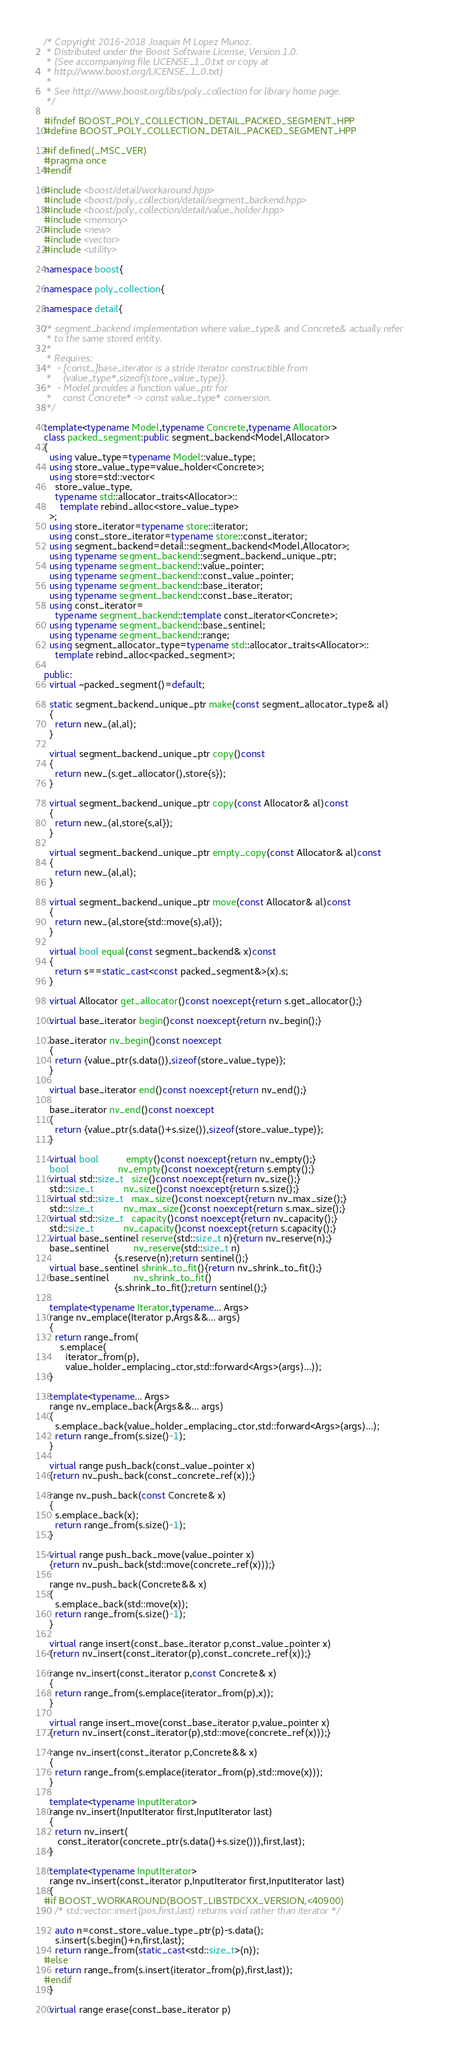Convert code to text. <code><loc_0><loc_0><loc_500><loc_500><_C++_>/* Copyright 2016-2018 Joaquin M Lopez Munoz.
 * Distributed under the Boost Software License, Version 1.0.
 * (See accompanying file LICENSE_1_0.txt or copy at
 * http://www.boost.org/LICENSE_1_0.txt)
 *
 * See http://www.boost.org/libs/poly_collection for library home page.
 */

#ifndef BOOST_POLY_COLLECTION_DETAIL_PACKED_SEGMENT_HPP
#define BOOST_POLY_COLLECTION_DETAIL_PACKED_SEGMENT_HPP

#if defined(_MSC_VER)
#pragma once
#endif

#include <boost/detail/workaround.hpp>
#include <boost/poly_collection/detail/segment_backend.hpp>
#include <boost/poly_collection/detail/value_holder.hpp>
#include <memory>
#include <new>
#include <vector>
#include <utility>

namespace boost{

namespace poly_collection{

namespace detail{

/* segment_backend implementation where value_type& and Concrete& actually refer
 * to the same stored entity.
 *
 * Requires:
 *  - [const_]base_iterator is a stride iterator constructible from
 *    {value_type*,sizeof(store_value_type)}.
 *  - Model provides a function value_ptr for
 *    const Concrete* -> const value_type* conversion.
 */

template<typename Model,typename Concrete,typename Allocator>
class packed_segment:public segment_backend<Model,Allocator>
{
  using value_type=typename Model::value_type;
  using store_value_type=value_holder<Concrete>;
  using store=std::vector<
    store_value_type,
    typename std::allocator_traits<Allocator>::
      template rebind_alloc<store_value_type>
  >;
  using store_iterator=typename store::iterator;
  using const_store_iterator=typename store::const_iterator;
  using segment_backend=detail::segment_backend<Model,Allocator>;
  using typename segment_backend::segment_backend_unique_ptr;
  using typename segment_backend::value_pointer;
  using typename segment_backend::const_value_pointer;
  using typename segment_backend::base_iterator;
  using typename segment_backend::const_base_iterator;
  using const_iterator=
    typename segment_backend::template const_iterator<Concrete>;
  using typename segment_backend::base_sentinel;
  using typename segment_backend::range;
  using segment_allocator_type=typename std::allocator_traits<Allocator>::
    template rebind_alloc<packed_segment>;

public:
  virtual ~packed_segment()=default;

  static segment_backend_unique_ptr make(const segment_allocator_type& al)
  {
    return new_(al,al);
  }

  virtual segment_backend_unique_ptr copy()const
  {
    return new_(s.get_allocator(),store{s});
  }

  virtual segment_backend_unique_ptr copy(const Allocator& al)const
  {
    return new_(al,store{s,al});
  }

  virtual segment_backend_unique_ptr empty_copy(const Allocator& al)const
  {
    return new_(al,al);
  }

  virtual segment_backend_unique_ptr move(const Allocator& al)const
  {
    return new_(al,store{std::move(s),al});
  }

  virtual bool equal(const segment_backend& x)const
  {
    return s==static_cast<const packed_segment&>(x).s;
  }

  virtual Allocator get_allocator()const noexcept{return s.get_allocator();}

  virtual base_iterator begin()const noexcept{return nv_begin();}

  base_iterator nv_begin()const noexcept
  {
    return {value_ptr(s.data()),sizeof(store_value_type)};
  }

  virtual base_iterator end()const noexcept{return nv_end();}

  base_iterator nv_end()const noexcept
  {
    return {value_ptr(s.data()+s.size()),sizeof(store_value_type)};
  }

  virtual bool          empty()const noexcept{return nv_empty();}
  bool                  nv_empty()const noexcept{return s.empty();}
  virtual std::size_t   size()const noexcept{return nv_size();}
  std::size_t           nv_size()const noexcept{return s.size();}
  virtual std::size_t   max_size()const noexcept{return nv_max_size();}
  std::size_t           nv_max_size()const noexcept{return s.max_size();}
  virtual std::size_t   capacity()const noexcept{return nv_capacity();}
  std::size_t           nv_capacity()const noexcept{return s.capacity();}
  virtual base_sentinel reserve(std::size_t n){return nv_reserve(n);}
  base_sentinel         nv_reserve(std::size_t n)
                          {s.reserve(n);return sentinel();}
  virtual base_sentinel shrink_to_fit(){return nv_shrink_to_fit();}
  base_sentinel         nv_shrink_to_fit()
                          {s.shrink_to_fit();return sentinel();}

  template<typename Iterator,typename... Args>
  range nv_emplace(Iterator p,Args&&... args)
  {
    return range_from(
      s.emplace(
        iterator_from(p),
        value_holder_emplacing_ctor,std::forward<Args>(args)...));
  }

  template<typename... Args>
  range nv_emplace_back(Args&&... args)
  {
    s.emplace_back(value_holder_emplacing_ctor,std::forward<Args>(args)...);
    return range_from(s.size()-1);
  }

  virtual range push_back(const_value_pointer x)
  {return nv_push_back(const_concrete_ref(x));}

  range nv_push_back(const Concrete& x)
  {
    s.emplace_back(x);
    return range_from(s.size()-1);
  }

  virtual range push_back_move(value_pointer x)
  {return nv_push_back(std::move(concrete_ref(x)));}

  range nv_push_back(Concrete&& x)
  {
    s.emplace_back(std::move(x));
    return range_from(s.size()-1);
  }

  virtual range insert(const_base_iterator p,const_value_pointer x)
  {return nv_insert(const_iterator(p),const_concrete_ref(x));}

  range nv_insert(const_iterator p,const Concrete& x)
  {
    return range_from(s.emplace(iterator_from(p),x));
  }

  virtual range insert_move(const_base_iterator p,value_pointer x)
  {return nv_insert(const_iterator(p),std::move(concrete_ref(x)));}

  range nv_insert(const_iterator p,Concrete&& x)
  {
    return range_from(s.emplace(iterator_from(p),std::move(x)));
  }

  template<typename InputIterator>
  range nv_insert(InputIterator first,InputIterator last)
  {
    return nv_insert(
     const_iterator(concrete_ptr(s.data()+s.size())),first,last);
  }

  template<typename InputIterator>
  range nv_insert(const_iterator p,InputIterator first,InputIterator last)
  {
#if BOOST_WORKAROUND(BOOST_LIBSTDCXX_VERSION,<40900)
    /* std::vector::insert(pos,first,last) returns void rather than iterator */

    auto n=const_store_value_type_ptr(p)-s.data();
    s.insert(s.begin()+n,first,last);
    return range_from(static_cast<std::size_t>(n)); 
#else
    return range_from(s.insert(iterator_from(p),first,last));
#endif
  }

  virtual range erase(const_base_iterator p)</code> 